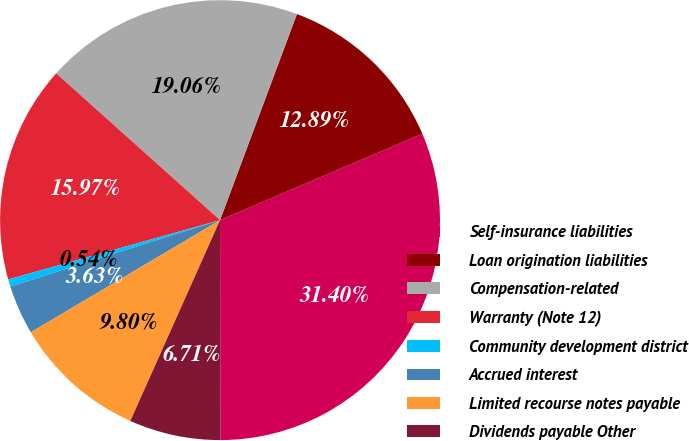<chart> <loc_0><loc_0><loc_500><loc_500><pie_chart><fcel>Self-insurance liabilities<fcel>Loan origination liabilities<fcel>Compensation-related<fcel>Warranty (Note 12)<fcel>Community development district<fcel>Accrued interest<fcel>Limited recourse notes payable<fcel>Dividends payable Other<nl><fcel>31.4%<fcel>12.89%<fcel>19.06%<fcel>15.97%<fcel>0.54%<fcel>3.63%<fcel>9.8%<fcel>6.71%<nl></chart> 